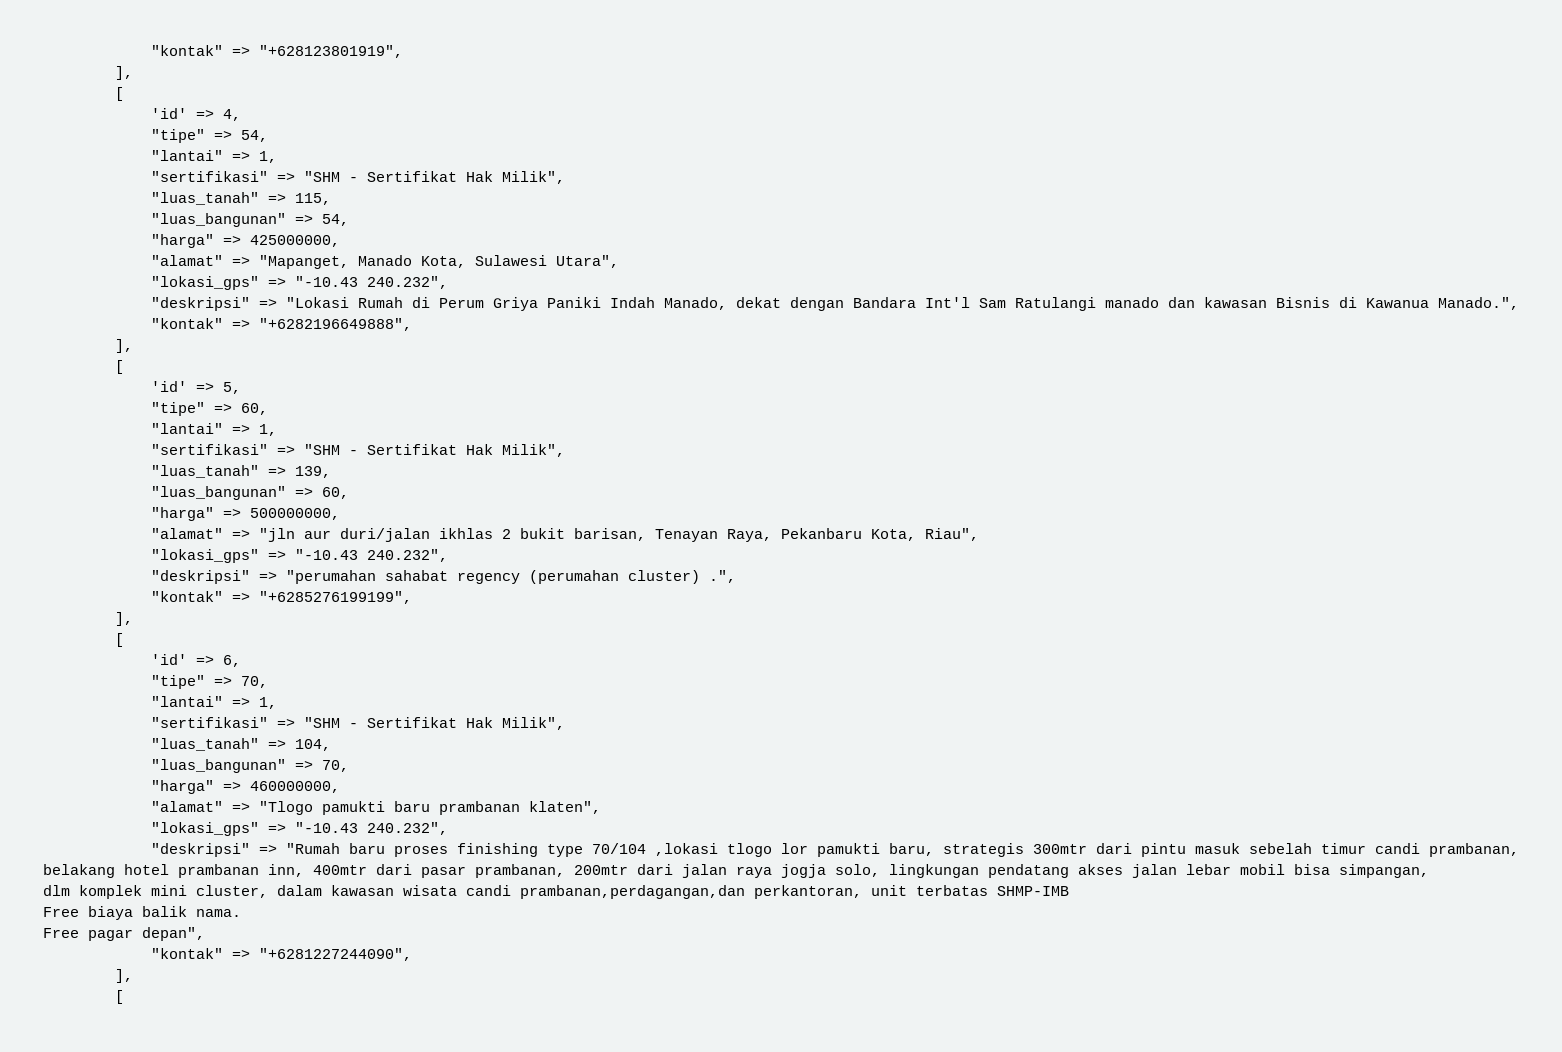Convert code to text. <code><loc_0><loc_0><loc_500><loc_500><_PHP_>			"kontak" => "+628123801919",
		],
		[
			'id' => 4,
			"tipe" => 54,
			"lantai" => 1,
			"sertifikasi" => "SHM - Sertifikat Hak Milik",
			"luas_tanah" => 115,
			"luas_bangunan" => 54,
			"harga" => 425000000,
			"alamat" => "Mapanget, Manado Kota, Sulawesi Utara",
			"lokasi_gps" => "-10.43 240.232",
			"deskripsi" => "Lokasi Rumah di Perum Griya Paniki Indah Manado, dekat dengan Bandara Int'l Sam Ratulangi manado dan kawasan Bisnis di Kawanua Manado.",
			"kontak" => "+6282196649888",
		],
		[
			'id' => 5,
			"tipe" => 60,
			"lantai" => 1,
			"sertifikasi" => "SHM - Sertifikat Hak Milik",
			"luas_tanah" => 139,
			"luas_bangunan" => 60,
			"harga" => 500000000,
			"alamat" => "jln aur duri/jalan ikhlas 2 bukit barisan, Tenayan Raya, Pekanbaru Kota, Riau",
			"lokasi_gps" => "-10.43 240.232",
			"deskripsi" => "perumahan sahabat regency (perumahan cluster) .",
			"kontak" => "+6285276199199",
		],
		[
			'id' => 6,
			"tipe" => 70,
			"lantai" => 1,
			"sertifikasi" => "SHM - Sertifikat Hak Milik",
			"luas_tanah" => 104,
			"luas_bangunan" => 70,
			"harga" => 460000000,
			"alamat" => "Tlogo pamukti baru prambanan klaten",
			"lokasi_gps" => "-10.43 240.232",
			"deskripsi" => "Rumah baru proses finishing type 70/104 ,lokasi tlogo lor pamukti baru, strategis 300mtr dari pintu masuk sebelah timur candi prambanan,
belakang hotel prambanan inn, 400mtr dari pasar prambanan, 200mtr dari jalan raya jogja solo, lingkungan pendatang akses jalan lebar mobil bisa simpangan,
dlm komplek mini cluster, dalam kawasan wisata candi prambanan,perdagangan,dan perkantoran, unit terbatas SHMP-IMB 
Free biaya balik nama.
Free pagar depan",
			"kontak" => "+6281227244090",
		],
		[</code> 